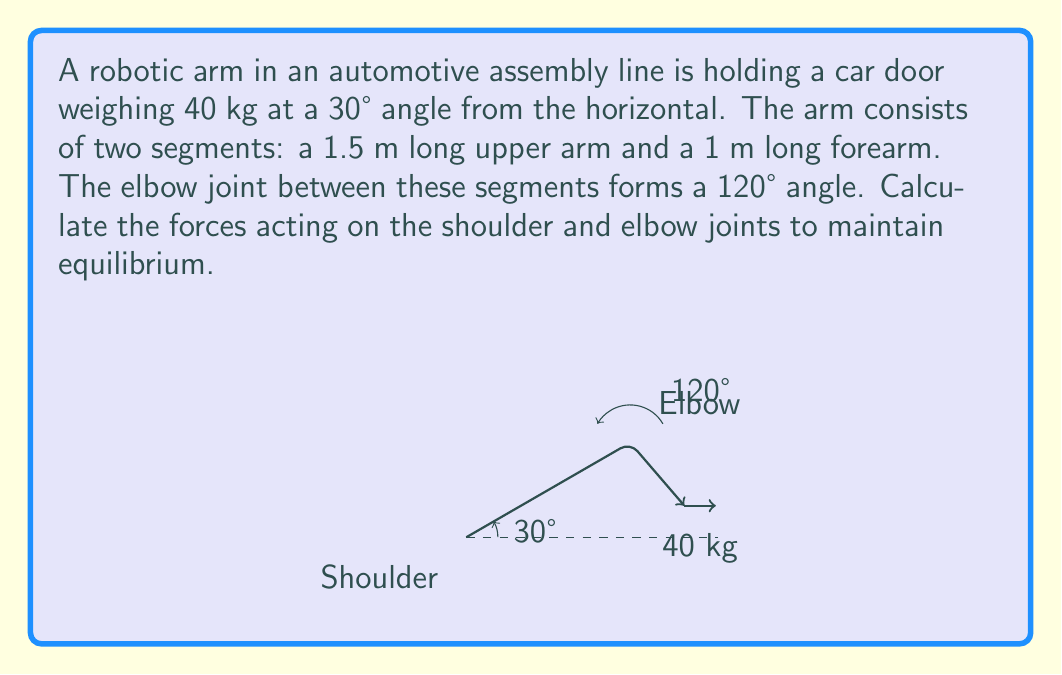Can you answer this question? To solve this problem, we'll use the principles of static equilibrium and break it down into steps:

1) First, let's identify the forces:
   - Weight of the door: $W = 40 \text{ kg} \times 9.8 \text{ m/s}^2 = 392 \text{ N}$
   - Force at shoulder joint: $F_s$
   - Force at elbow joint: $F_e$

2) We can break down the forces at each joint into x and y components:
   $F_{sx}, F_{sy}, F_{ex}, F_{ey}$

3) For equilibrium, the sum of forces in both x and y directions must be zero, and the sum of moments about any point must be zero. Let's choose the shoulder as our reference point for moments.

4) Sum of forces in x-direction:
   $$F_{sx} + F_{ex} - W \sin(30°) = 0$$

5) Sum of forces in y-direction:
   $$F_{sy} + F_{ey} - W \cos(30°) = 0$$

6) Sum of moments about the shoulder (counterclockwise positive):
   $$F_{ey} \cdot 1.5 \cos(30°) - F_{ex} \cdot 1.5 \sin(30°) - W \cdot 2.5 \cos(30°) = 0$$

7) We now have three equations and four unknowns. We need one more equation, which comes from the angle at the elbow:
   $$\tan(120°) = \frac{F_{ey}}{F_{ex}}$$

8) Solving this system of equations:
   From (7): $F_{ey} = -\sqrt{3} F_{ex}$
   
   Substituting into (6):
   $$-\sqrt{3} F_{ex} \cdot 1.5 \cos(30°) - F_{ex} \cdot 1.5 \sin(30°) - 392 \cdot 2.5 \cos(30°) = 0$$
   $$F_{ex} (-\sqrt{3} \cdot 1.5 \cdot \frac{\sqrt{3}}{2} - 1.5 \cdot 0.5) = 392 \cdot 2.5 \cdot \frac{\sqrt{3}}{2}$$
   $$F_{ex} = -226.08 \text{ N}$$
   
   Therefore, $F_{ey} = 391.58 \text{ N}$

   From (4) and (5):
   $$F_{sx} = 392 \sin(30°) + 226.08 = 422.08 \text{ N}$$
   $$F_{sy} = 392 \cos(30°) - 391.58 = -51.58 \text{ N}$$

9) The magnitudes of the forces are:
   $$F_e = \sqrt{F_{ex}^2 + F_{ey}^2} = 452.77 \text{ N}$$
   $$F_s = \sqrt{F_{sx}^2 + F_{sy}^2} = 425.19 \text{ N}$$
Answer: $F_e = 452.77 \text{ N}, F_s = 425.19 \text{ N}$ 